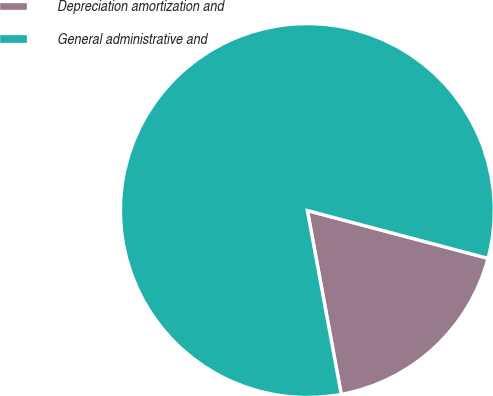Convert chart. <chart><loc_0><loc_0><loc_500><loc_500><pie_chart><fcel>Depreciation amortization and<fcel>General administrative and<nl><fcel>17.98%<fcel>82.02%<nl></chart> 